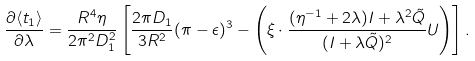Convert formula to latex. <formula><loc_0><loc_0><loc_500><loc_500>\frac { \partial \langle t _ { 1 } \rangle } { \partial \lambda } = \frac { R ^ { 4 } \eta } { 2 \pi ^ { 2 } D _ { 1 } ^ { 2 } } \left [ \frac { 2 \pi D _ { 1 } } { 3 R ^ { 2 } } ( \pi - \epsilon ) ^ { 3 } - \left ( \xi \cdot \frac { ( \eta ^ { - 1 } + 2 \lambda ) I + \lambda ^ { 2 } \tilde { Q } } { ( I + \lambda \tilde { Q } ) ^ { 2 } } U \right ) \right ] .</formula> 